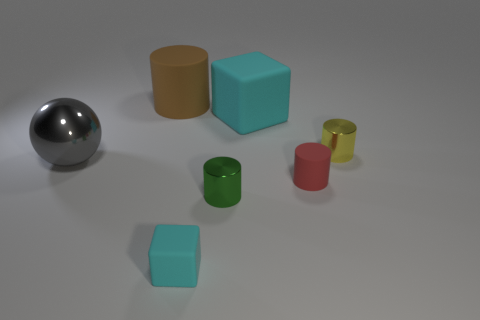Subtract all red rubber cylinders. How many cylinders are left? 3 Subtract 2 cylinders. How many cylinders are left? 2 Add 2 large yellow objects. How many objects exist? 9 Subtract all gray cylinders. Subtract all cyan cubes. How many cylinders are left? 4 Subtract all cylinders. How many objects are left? 3 Subtract all large purple metal objects. Subtract all small rubber things. How many objects are left? 5 Add 2 small green cylinders. How many small green cylinders are left? 3 Add 6 rubber objects. How many rubber objects exist? 10 Subtract 0 red cubes. How many objects are left? 7 